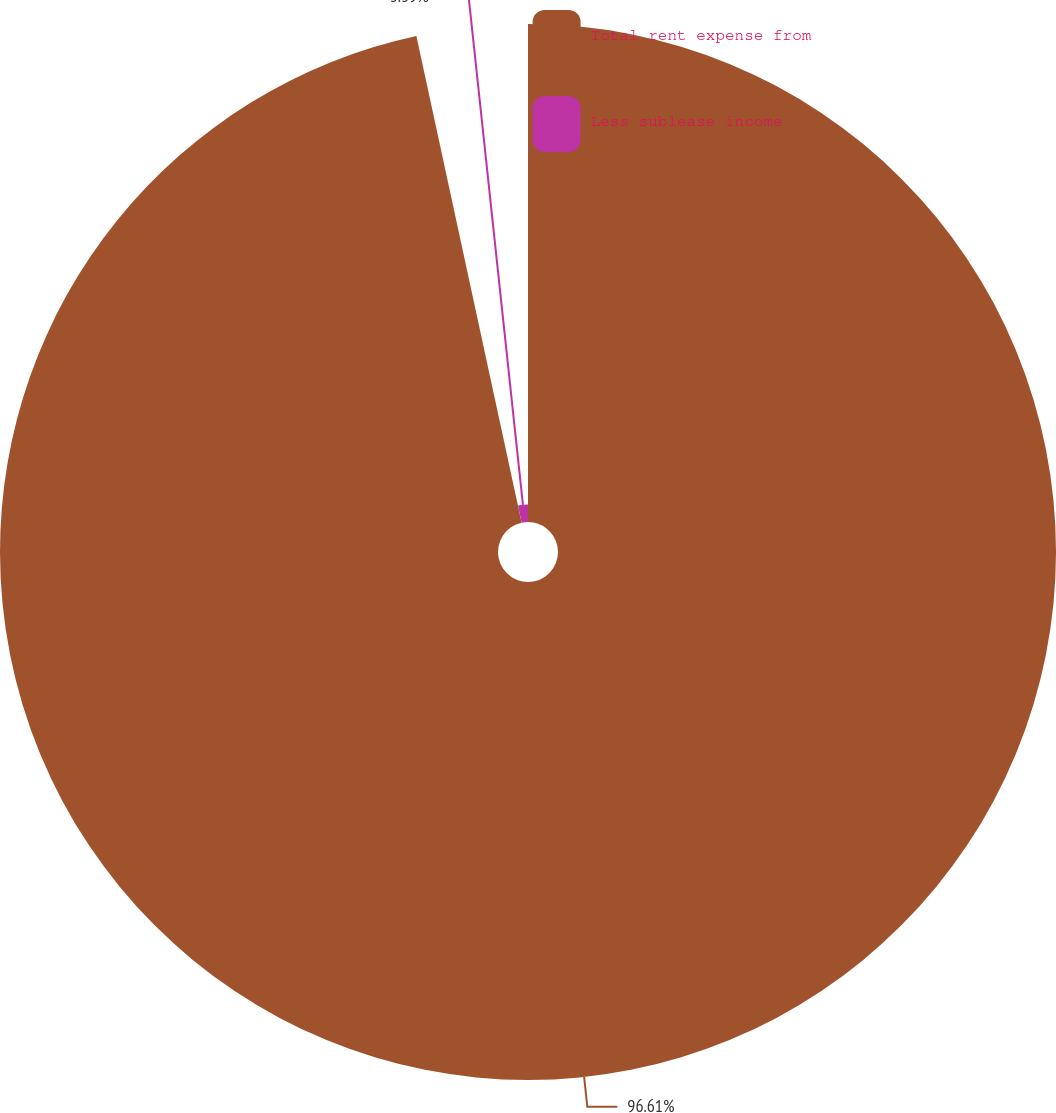<chart> <loc_0><loc_0><loc_500><loc_500><pie_chart><fcel>Total rent expense from<fcel>Less sublease income<nl><fcel>96.61%<fcel>3.39%<nl></chart> 